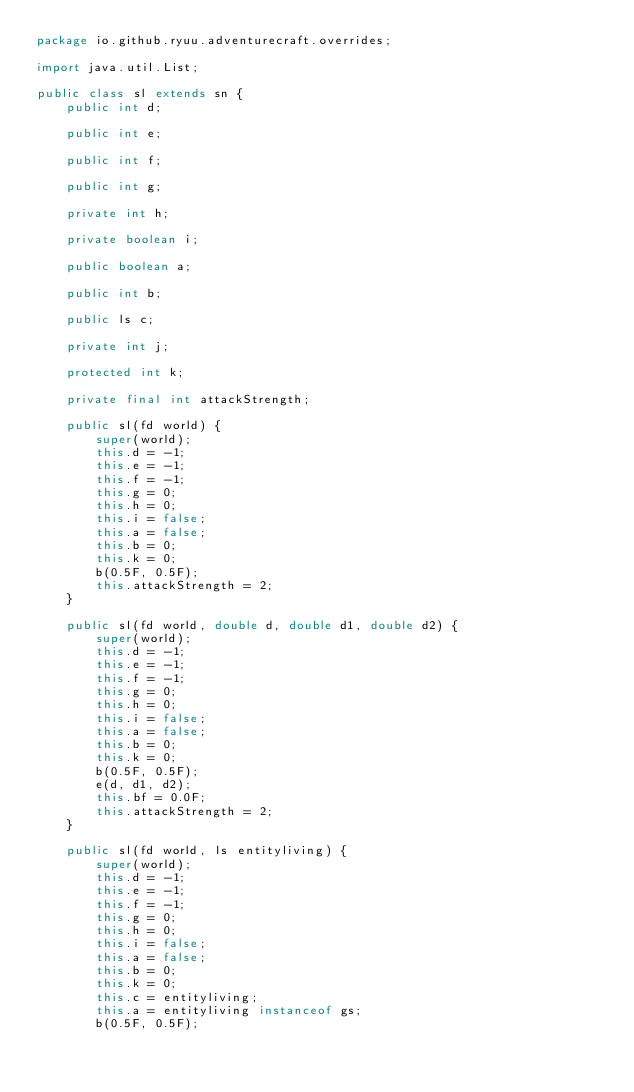Convert code to text. <code><loc_0><loc_0><loc_500><loc_500><_Java_>package io.github.ryuu.adventurecraft.overrides;

import java.util.List;

public class sl extends sn {
    public int d;

    public int e;

    public int f;

    public int g;

    private int h;

    private boolean i;

    public boolean a;

    public int b;

    public ls c;

    private int j;

    protected int k;

    private final int attackStrength;

    public sl(fd world) {
        super(world);
        this.d = -1;
        this.e = -1;
        this.f = -1;
        this.g = 0;
        this.h = 0;
        this.i = false;
        this.a = false;
        this.b = 0;
        this.k = 0;
        b(0.5F, 0.5F);
        this.attackStrength = 2;
    }

    public sl(fd world, double d, double d1, double d2) {
        super(world);
        this.d = -1;
        this.e = -1;
        this.f = -1;
        this.g = 0;
        this.h = 0;
        this.i = false;
        this.a = false;
        this.b = 0;
        this.k = 0;
        b(0.5F, 0.5F);
        e(d, d1, d2);
        this.bf = 0.0F;
        this.attackStrength = 2;
    }

    public sl(fd world, ls entityliving) {
        super(world);
        this.d = -1;
        this.e = -1;
        this.f = -1;
        this.g = 0;
        this.h = 0;
        this.i = false;
        this.a = false;
        this.b = 0;
        this.k = 0;
        this.c = entityliving;
        this.a = entityliving instanceof gs;
        b(0.5F, 0.5F);</code> 